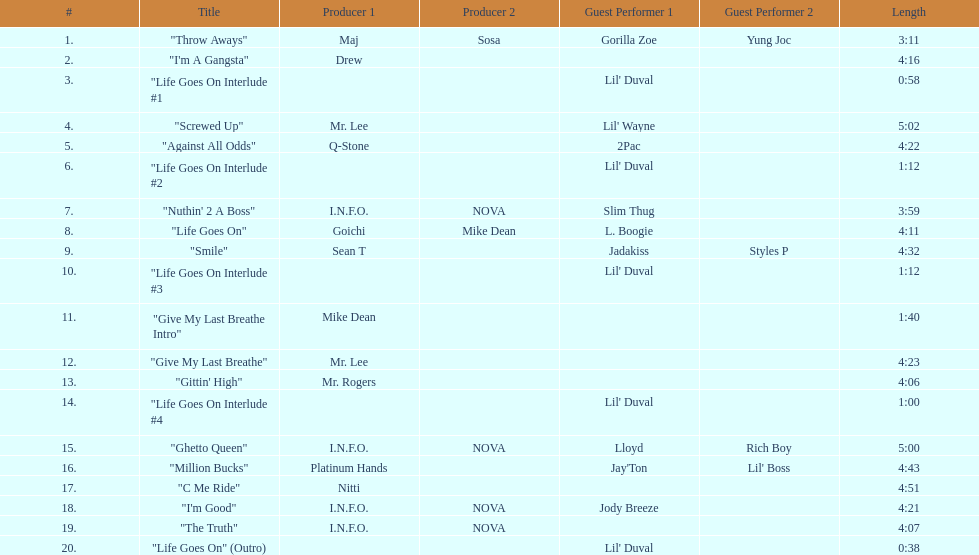Which tracks feature the same producer(s) in consecutive order on this album? "I'm Good", "The Truth". 